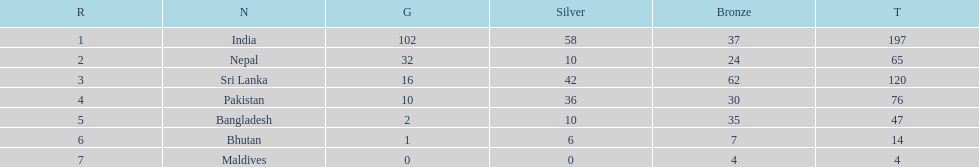Select a country featured in the list, not including india? Nepal. 